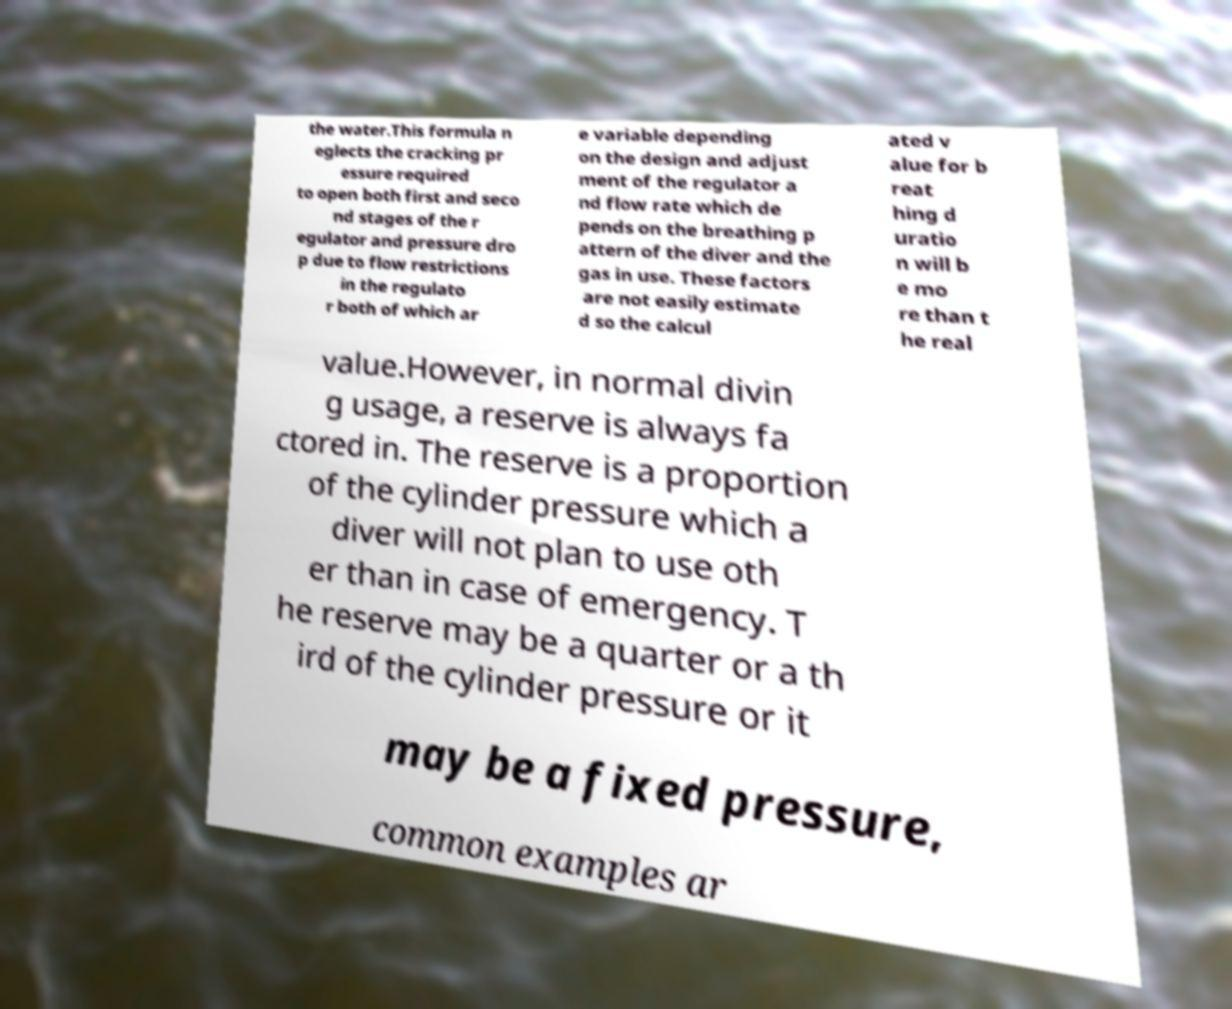For documentation purposes, I need the text within this image transcribed. Could you provide that? the water.This formula n eglects the cracking pr essure required to open both first and seco nd stages of the r egulator and pressure dro p due to flow restrictions in the regulato r both of which ar e variable depending on the design and adjust ment of the regulator a nd flow rate which de pends on the breathing p attern of the diver and the gas in use. These factors are not easily estimate d so the calcul ated v alue for b reat hing d uratio n will b e mo re than t he real value.However, in normal divin g usage, a reserve is always fa ctored in. The reserve is a proportion of the cylinder pressure which a diver will not plan to use oth er than in case of emergency. T he reserve may be a quarter or a th ird of the cylinder pressure or it may be a fixed pressure, common examples ar 